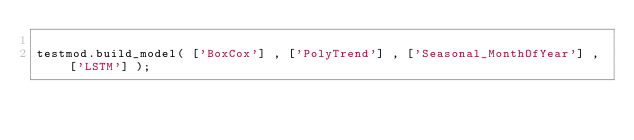Convert code to text. <code><loc_0><loc_0><loc_500><loc_500><_Python_>
testmod.build_model( ['BoxCox'] , ['PolyTrend'] , ['Seasonal_MonthOfYear'] , ['LSTM'] );</code> 